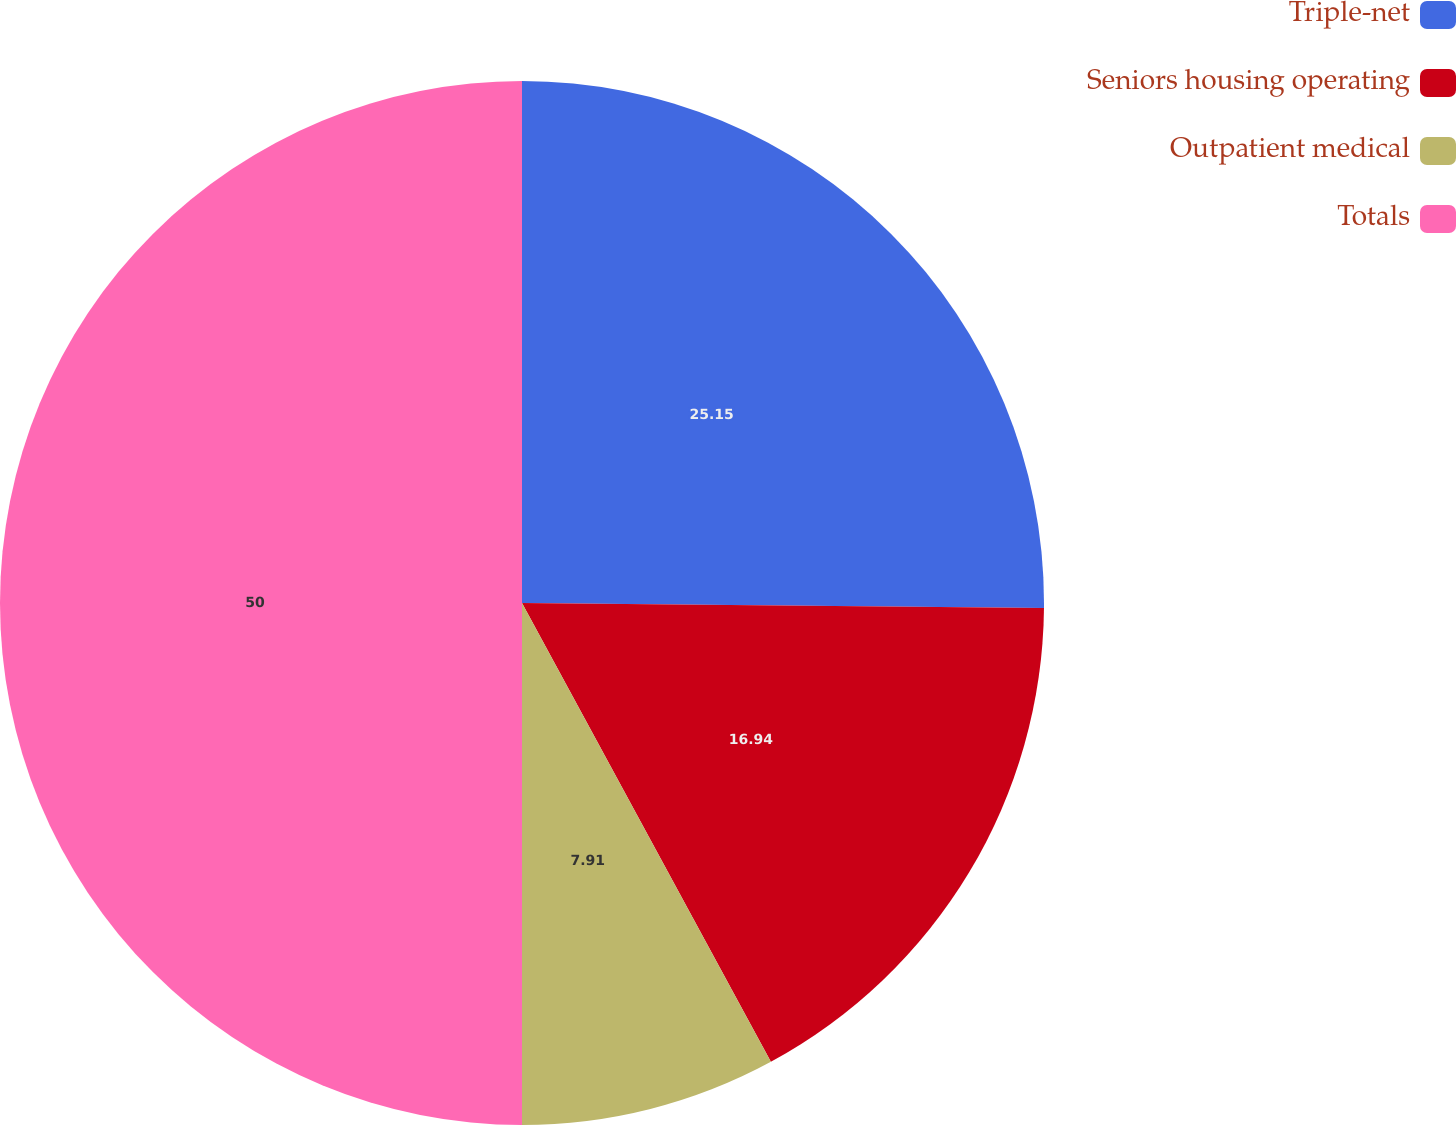Convert chart to OTSL. <chart><loc_0><loc_0><loc_500><loc_500><pie_chart><fcel>Triple-net<fcel>Seniors housing operating<fcel>Outpatient medical<fcel>Totals<nl><fcel>25.15%<fcel>16.94%<fcel>7.91%<fcel>50.0%<nl></chart> 